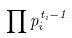Convert formula to latex. <formula><loc_0><loc_0><loc_500><loc_500>\prod p _ { i } ^ { t _ { i } - 1 }</formula> 